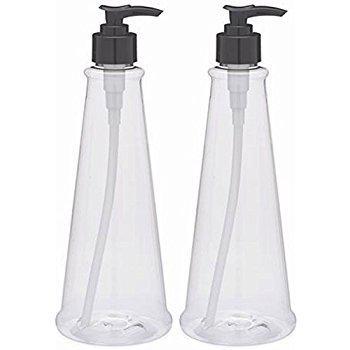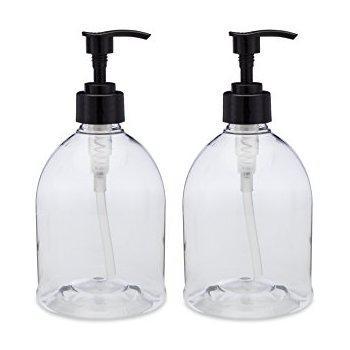The first image is the image on the left, the second image is the image on the right. Analyze the images presented: Is the assertion "The right image contains at least two dispensers." valid? Answer yes or no. Yes. The first image is the image on the left, the second image is the image on the right. Examine the images to the left and right. Is the description "The combined images show four complete pump-top dispensers, all of them transparent." accurate? Answer yes or no. Yes. 